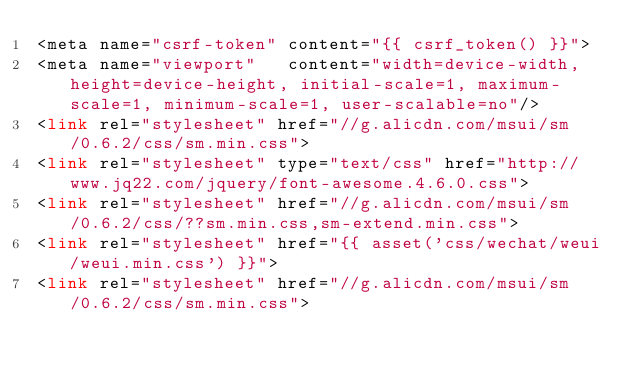<code> <loc_0><loc_0><loc_500><loc_500><_PHP_><meta name="csrf-token" content="{{ csrf_token() }}">
<meta name="viewport"   content="width=device-width, height=device-height, initial-scale=1, maximum-scale=1, minimum-scale=1, user-scalable=no"/>
<link rel="stylesheet" href="//g.alicdn.com/msui/sm/0.6.2/css/sm.min.css">
<link rel="stylesheet" type="text/css" href="http://www.jq22.com/jquery/font-awesome.4.6.0.css">
<link rel="stylesheet" href="//g.alicdn.com/msui/sm/0.6.2/css/??sm.min.css,sm-extend.min.css">
<link rel="stylesheet" href="{{ asset('css/wechat/weui/weui.min.css') }}">
<link rel="stylesheet" href="//g.alicdn.com/msui/sm/0.6.2/css/sm.min.css"></code> 